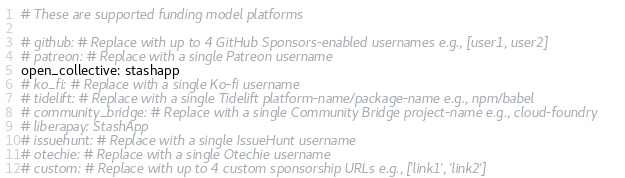Convert code to text. <code><loc_0><loc_0><loc_500><loc_500><_YAML_># These are supported funding model platforms

# github: # Replace with up to 4 GitHub Sponsors-enabled usernames e.g., [user1, user2]
# patreon: # Replace with a single Patreon username
open_collective: stashapp
# ko_fi: # Replace with a single Ko-fi username
# tidelift: # Replace with a single Tidelift platform-name/package-name e.g., npm/babel
# community_bridge: # Replace with a single Community Bridge project-name e.g., cloud-foundry
# liberapay: StashApp
# issuehunt: # Replace with a single IssueHunt username
# otechie: # Replace with a single Otechie username
# custom: # Replace with up to 4 custom sponsorship URLs e.g., ['link1', 'link2']
</code> 